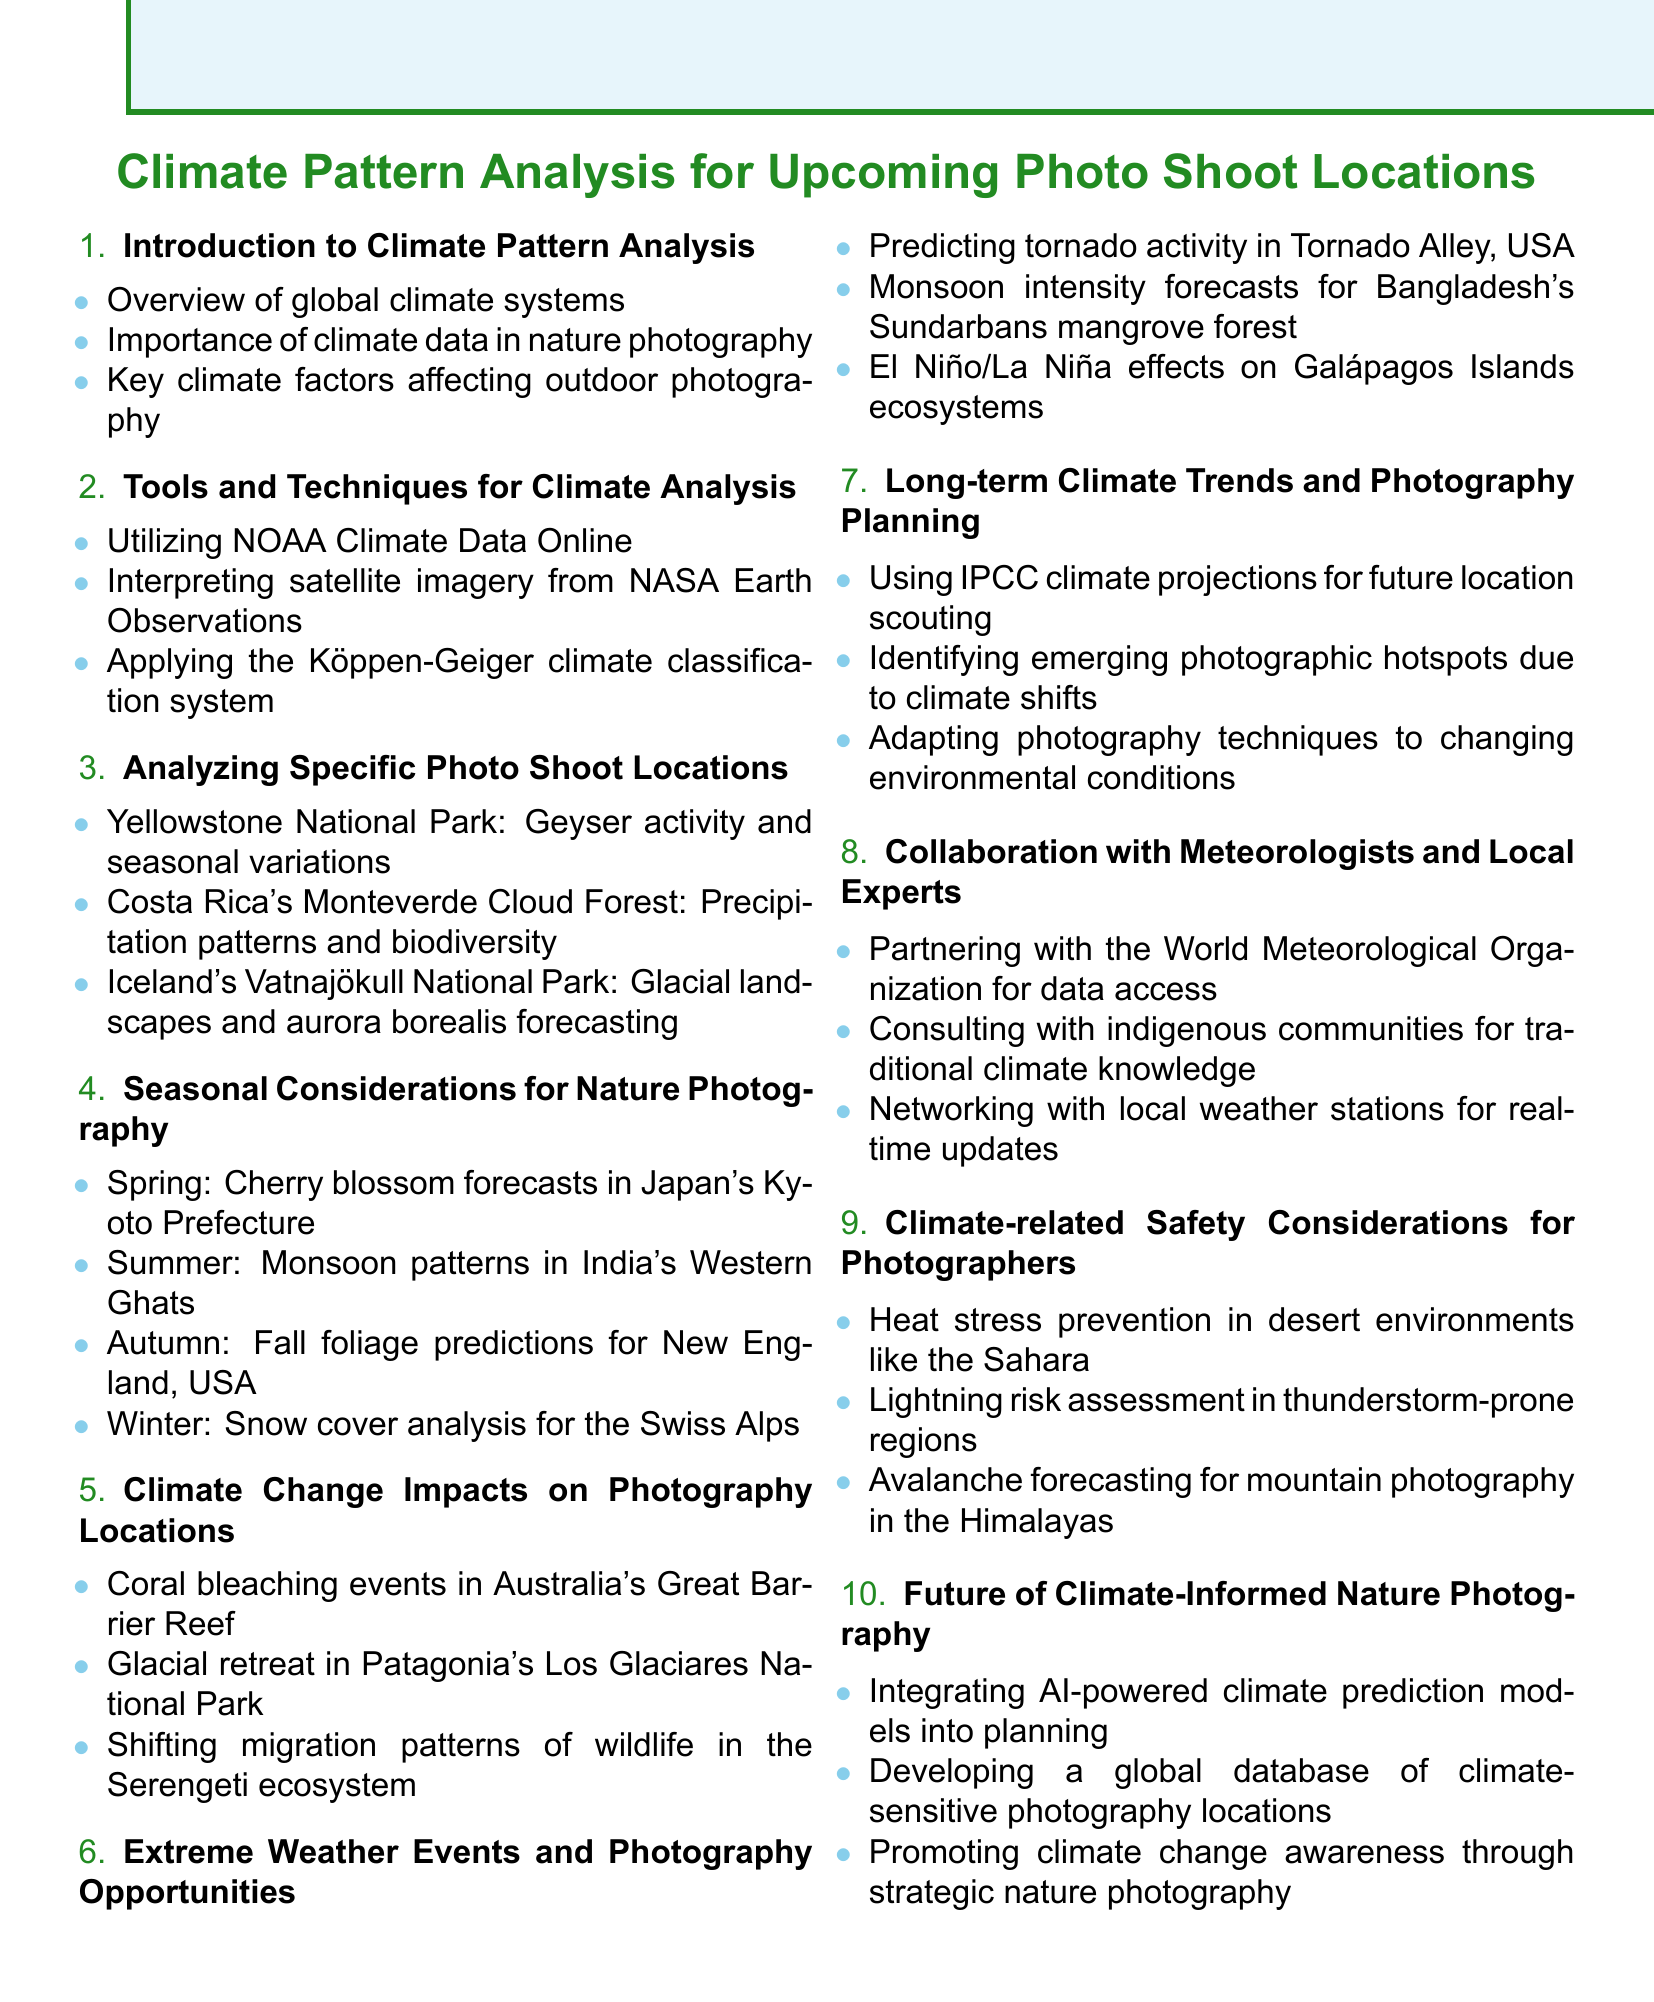What is the title of the document? The title of the document is presented at the top of the rendered agenda.
Answer: Climate Pattern Analysis for Upcoming Photo Shoot Locations How many items are listed in the agenda? The agenda contains a total of ten items detailed in the list format.
Answer: 10 What is the focus of the section regarding Yellowstone National Park? The section mentions specific characteristics of Yellowstone that are crucial for photography.
Answer: Geyser activity and seasonal variations What seasonal photography considerations are mentioned for Autumn? This detail specifically pertains to predictions related to a seasonal phenomenon in a geographic area.
Answer: Fall foliage predictions for New England, USA Which weather phenomenon is discussed in relation to Bangladesh's Sundarbans? The agenda addresses specific weather patterns that are significant for photography opportunities in a specific region.
Answer: Monsoon intensity forecasts What type of database is proposed for future photography planning? This item suggests the creation of a specific tool for photographers regarding climate-sensitive regions.
Answer: A global database of climate-sensitive photography locations Which organization is mentioned for collaboration on data access? The agenda references an international organization that focuses on meteorology and climate issues.
Answer: World Meteorological Organization What climate change impact is associated with the Great Barrier Reef? This section highlights a significant environmental issue impacting a famous natural location.
Answer: Coral bleaching events Which climate classification system is mentioned in the agenda? This refers to a systematic methodology for categorizing weather patterns that could affect outdoor photography.
Answer: Köppen-Geiger climate classification system 